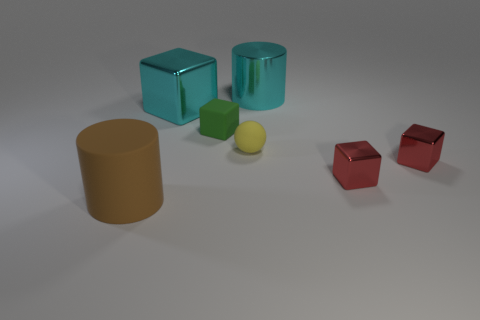Is the number of large metallic cylinders greater than the number of small rubber things?
Offer a very short reply. No. There is a metal object that is the same color as the large block; what is its size?
Offer a terse response. Large. What size is the cube that is both to the left of the small yellow object and in front of the big metal block?
Keep it short and to the point. Small. The cylinder that is on the left side of the metal object behind the big cyan metallic object left of the yellow rubber sphere is made of what material?
Your answer should be very brief. Rubber. There is a block that is the same color as the large metal cylinder; what material is it?
Keep it short and to the point. Metal. Is the color of the large shiny thing on the right side of the tiny matte ball the same as the metallic block to the left of the large metallic cylinder?
Make the answer very short. Yes. There is a large metallic object that is in front of the big metallic thing right of the shiny block that is on the left side of the metallic cylinder; what is its shape?
Your answer should be compact. Cube. What is the shape of the object that is both on the right side of the sphere and behind the green rubber cube?
Your answer should be compact. Cylinder. What number of large cyan metal cylinders are behind the cylinder behind the matte object that is to the left of the tiny green matte object?
Your answer should be very brief. 0. Does the cylinder left of the tiny rubber cube have the same material as the cyan cylinder?
Ensure brevity in your answer.  No. 